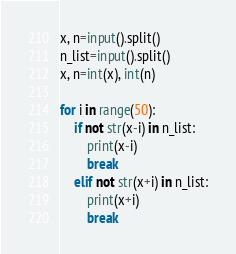<code> <loc_0><loc_0><loc_500><loc_500><_Python_>x, n=input().split()
n_list=input().split()
x, n=int(x), int(n)

for i in range(50):
    if not str(x-i) in n_list:
        print(x-i)
        break
    elif not str(x+i) in n_list:
        print(x+i)
        break
</code> 